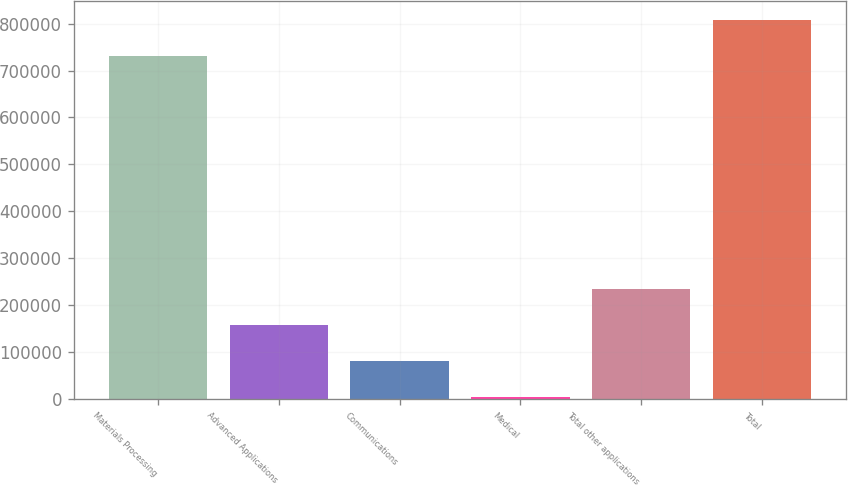Convert chart. <chart><loc_0><loc_0><loc_500><loc_500><bar_chart><fcel>Materials Processing<fcel>Advanced Applications<fcel>Communications<fcel>Medical<fcel>Total other applications<fcel>Total<nl><fcel>731274<fcel>157431<fcel>80881.1<fcel>4331<fcel>233981<fcel>807824<nl></chart> 